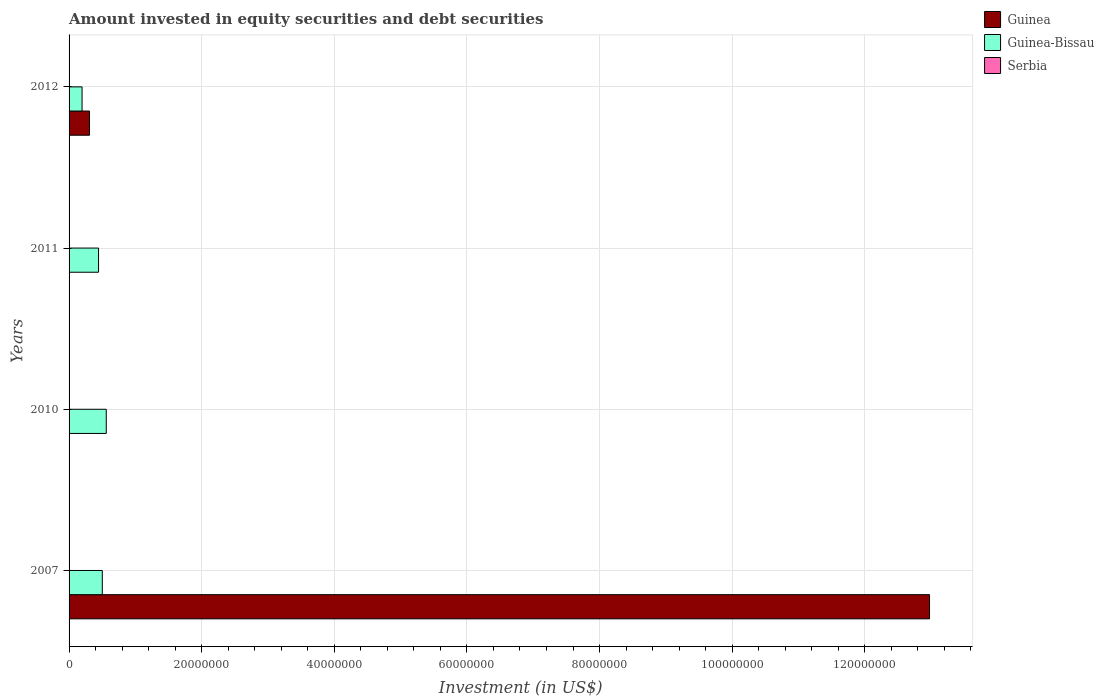How many bars are there on the 1st tick from the bottom?
Make the answer very short. 2. What is the amount invested in equity securities and debt securities in Guinea-Bissau in 2007?
Give a very brief answer. 5.01e+06. Across all years, what is the maximum amount invested in equity securities and debt securities in Guinea-Bissau?
Provide a short and direct response. 5.61e+06. Across all years, what is the minimum amount invested in equity securities and debt securities in Guinea-Bissau?
Keep it short and to the point. 1.96e+06. What is the difference between the amount invested in equity securities and debt securities in Guinea-Bissau in 2011 and that in 2012?
Provide a succinct answer. 2.49e+06. What is the difference between the amount invested in equity securities and debt securities in Serbia in 2011 and the amount invested in equity securities and debt securities in Guinea in 2012?
Offer a terse response. -3.08e+06. What is the average amount invested in equity securities and debt securities in Guinea per year?
Provide a short and direct response. 3.32e+07. In the year 2007, what is the difference between the amount invested in equity securities and debt securities in Guinea-Bissau and amount invested in equity securities and debt securities in Guinea?
Give a very brief answer. -1.25e+08. What is the difference between the highest and the lowest amount invested in equity securities and debt securities in Guinea-Bissau?
Provide a short and direct response. 3.65e+06. How many bars are there?
Your answer should be compact. 6. How many years are there in the graph?
Keep it short and to the point. 4. Are the values on the major ticks of X-axis written in scientific E-notation?
Your answer should be very brief. No. Where does the legend appear in the graph?
Keep it short and to the point. Top right. What is the title of the graph?
Offer a terse response. Amount invested in equity securities and debt securities. What is the label or title of the X-axis?
Give a very brief answer. Investment (in US$). What is the Investment (in US$) in Guinea in 2007?
Your answer should be very brief. 1.30e+08. What is the Investment (in US$) of Guinea-Bissau in 2007?
Provide a short and direct response. 5.01e+06. What is the Investment (in US$) in Guinea-Bissau in 2010?
Offer a terse response. 5.61e+06. What is the Investment (in US$) in Guinea-Bissau in 2011?
Provide a short and direct response. 4.45e+06. What is the Investment (in US$) of Serbia in 2011?
Your answer should be very brief. 0. What is the Investment (in US$) of Guinea in 2012?
Your answer should be very brief. 3.08e+06. What is the Investment (in US$) in Guinea-Bissau in 2012?
Offer a very short reply. 1.96e+06. What is the Investment (in US$) of Serbia in 2012?
Your answer should be very brief. 0. Across all years, what is the maximum Investment (in US$) in Guinea?
Make the answer very short. 1.30e+08. Across all years, what is the maximum Investment (in US$) of Guinea-Bissau?
Give a very brief answer. 5.61e+06. Across all years, what is the minimum Investment (in US$) of Guinea-Bissau?
Provide a succinct answer. 1.96e+06. What is the total Investment (in US$) of Guinea in the graph?
Your answer should be very brief. 1.33e+08. What is the total Investment (in US$) in Guinea-Bissau in the graph?
Keep it short and to the point. 1.70e+07. What is the difference between the Investment (in US$) of Guinea-Bissau in 2007 and that in 2010?
Provide a succinct answer. -6.00e+05. What is the difference between the Investment (in US$) in Guinea-Bissau in 2007 and that in 2011?
Provide a short and direct response. 5.64e+05. What is the difference between the Investment (in US$) of Guinea in 2007 and that in 2012?
Keep it short and to the point. 1.27e+08. What is the difference between the Investment (in US$) in Guinea-Bissau in 2007 and that in 2012?
Provide a succinct answer. 3.05e+06. What is the difference between the Investment (in US$) in Guinea-Bissau in 2010 and that in 2011?
Ensure brevity in your answer.  1.16e+06. What is the difference between the Investment (in US$) of Guinea-Bissau in 2010 and that in 2012?
Ensure brevity in your answer.  3.65e+06. What is the difference between the Investment (in US$) in Guinea-Bissau in 2011 and that in 2012?
Offer a terse response. 2.49e+06. What is the difference between the Investment (in US$) of Guinea in 2007 and the Investment (in US$) of Guinea-Bissau in 2010?
Give a very brief answer. 1.24e+08. What is the difference between the Investment (in US$) in Guinea in 2007 and the Investment (in US$) in Guinea-Bissau in 2011?
Offer a terse response. 1.25e+08. What is the difference between the Investment (in US$) in Guinea in 2007 and the Investment (in US$) in Guinea-Bissau in 2012?
Ensure brevity in your answer.  1.28e+08. What is the average Investment (in US$) in Guinea per year?
Ensure brevity in your answer.  3.32e+07. What is the average Investment (in US$) in Guinea-Bissau per year?
Your answer should be compact. 4.26e+06. In the year 2007, what is the difference between the Investment (in US$) of Guinea and Investment (in US$) of Guinea-Bissau?
Keep it short and to the point. 1.25e+08. In the year 2012, what is the difference between the Investment (in US$) of Guinea and Investment (in US$) of Guinea-Bissau?
Provide a short and direct response. 1.12e+06. What is the ratio of the Investment (in US$) of Guinea-Bissau in 2007 to that in 2010?
Keep it short and to the point. 0.89. What is the ratio of the Investment (in US$) in Guinea-Bissau in 2007 to that in 2011?
Give a very brief answer. 1.13. What is the ratio of the Investment (in US$) of Guinea in 2007 to that in 2012?
Provide a succinct answer. 42.13. What is the ratio of the Investment (in US$) of Guinea-Bissau in 2007 to that in 2012?
Provide a short and direct response. 2.56. What is the ratio of the Investment (in US$) of Guinea-Bissau in 2010 to that in 2011?
Keep it short and to the point. 1.26. What is the ratio of the Investment (in US$) of Guinea-Bissau in 2010 to that in 2012?
Give a very brief answer. 2.86. What is the ratio of the Investment (in US$) in Guinea-Bissau in 2011 to that in 2012?
Ensure brevity in your answer.  2.27. What is the difference between the highest and the second highest Investment (in US$) in Guinea-Bissau?
Give a very brief answer. 6.00e+05. What is the difference between the highest and the lowest Investment (in US$) in Guinea?
Your response must be concise. 1.30e+08. What is the difference between the highest and the lowest Investment (in US$) in Guinea-Bissau?
Provide a short and direct response. 3.65e+06. 